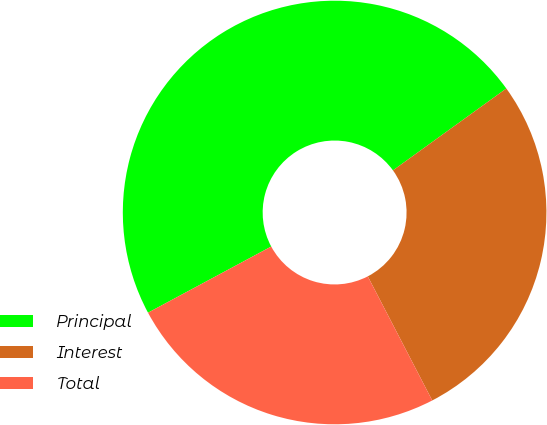<chart> <loc_0><loc_0><loc_500><loc_500><pie_chart><fcel>Principal<fcel>Interest<fcel>Total<nl><fcel>47.89%<fcel>27.33%<fcel>24.78%<nl></chart> 